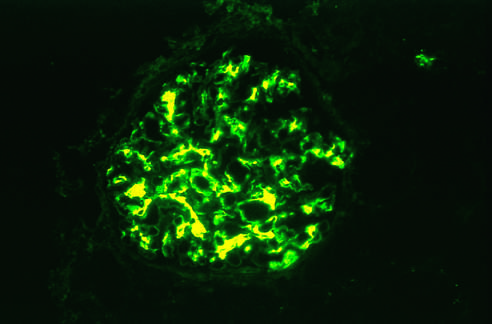s characteristic immunofluorescence deposition of iga, principally in mesangial regions, evident?
Answer the question using a single word or phrase. Yes 